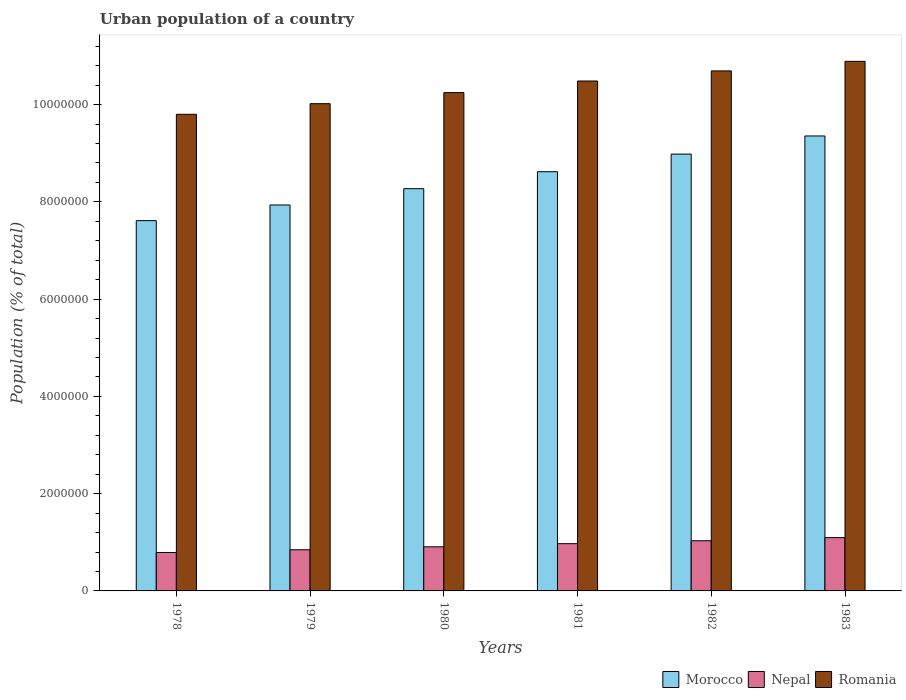How many different coloured bars are there?
Your answer should be compact. 3. Are the number of bars on each tick of the X-axis equal?
Your answer should be very brief. Yes. How many bars are there on the 3rd tick from the left?
Offer a terse response. 3. What is the label of the 5th group of bars from the left?
Keep it short and to the point. 1982. In how many cases, is the number of bars for a given year not equal to the number of legend labels?
Your answer should be very brief. 0. What is the urban population in Nepal in 1982?
Your answer should be compact. 1.03e+06. Across all years, what is the maximum urban population in Morocco?
Offer a very short reply. 9.36e+06. Across all years, what is the minimum urban population in Morocco?
Keep it short and to the point. 7.61e+06. In which year was the urban population in Nepal maximum?
Make the answer very short. 1983. In which year was the urban population in Nepal minimum?
Ensure brevity in your answer.  1978. What is the total urban population in Morocco in the graph?
Ensure brevity in your answer.  5.08e+07. What is the difference between the urban population in Nepal in 1978 and that in 1981?
Your answer should be compact. -1.81e+05. What is the difference between the urban population in Morocco in 1981 and the urban population in Nepal in 1980?
Keep it short and to the point. 7.71e+06. What is the average urban population in Nepal per year?
Your answer should be compact. 9.40e+05. In the year 1979, what is the difference between the urban population in Romania and urban population in Nepal?
Keep it short and to the point. 9.17e+06. What is the ratio of the urban population in Nepal in 1979 to that in 1981?
Provide a short and direct response. 0.87. Is the difference between the urban population in Romania in 1978 and 1982 greater than the difference between the urban population in Nepal in 1978 and 1982?
Provide a short and direct response. No. What is the difference between the highest and the second highest urban population in Morocco?
Your response must be concise. 3.73e+05. What is the difference between the highest and the lowest urban population in Nepal?
Your answer should be compact. 3.06e+05. In how many years, is the urban population in Nepal greater than the average urban population in Nepal taken over all years?
Give a very brief answer. 3. What does the 3rd bar from the left in 1983 represents?
Ensure brevity in your answer.  Romania. What does the 3rd bar from the right in 1980 represents?
Make the answer very short. Morocco. Is it the case that in every year, the sum of the urban population in Nepal and urban population in Romania is greater than the urban population in Morocco?
Give a very brief answer. Yes. Are all the bars in the graph horizontal?
Keep it short and to the point. No. Are the values on the major ticks of Y-axis written in scientific E-notation?
Offer a terse response. No. Does the graph contain any zero values?
Give a very brief answer. No. Does the graph contain grids?
Ensure brevity in your answer.  No. How many legend labels are there?
Offer a terse response. 3. What is the title of the graph?
Offer a very short reply. Urban population of a country. Does "Tanzania" appear as one of the legend labels in the graph?
Provide a succinct answer. No. What is the label or title of the X-axis?
Provide a succinct answer. Years. What is the label or title of the Y-axis?
Make the answer very short. Population (% of total). What is the Population (% of total) of Morocco in 1978?
Provide a succinct answer. 7.61e+06. What is the Population (% of total) of Nepal in 1978?
Your answer should be compact. 7.90e+05. What is the Population (% of total) in Romania in 1978?
Your answer should be compact. 9.80e+06. What is the Population (% of total) of Morocco in 1979?
Ensure brevity in your answer.  7.94e+06. What is the Population (% of total) in Nepal in 1979?
Give a very brief answer. 8.46e+05. What is the Population (% of total) of Romania in 1979?
Your answer should be very brief. 1.00e+07. What is the Population (% of total) of Morocco in 1980?
Offer a terse response. 8.27e+06. What is the Population (% of total) in Nepal in 1980?
Offer a very short reply. 9.07e+05. What is the Population (% of total) in Romania in 1980?
Make the answer very short. 1.02e+07. What is the Population (% of total) of Morocco in 1981?
Ensure brevity in your answer.  8.62e+06. What is the Population (% of total) in Nepal in 1981?
Keep it short and to the point. 9.72e+05. What is the Population (% of total) in Romania in 1981?
Keep it short and to the point. 1.05e+07. What is the Population (% of total) of Morocco in 1982?
Your response must be concise. 8.98e+06. What is the Population (% of total) in Nepal in 1982?
Offer a very short reply. 1.03e+06. What is the Population (% of total) of Romania in 1982?
Keep it short and to the point. 1.07e+07. What is the Population (% of total) of Morocco in 1983?
Offer a very short reply. 9.36e+06. What is the Population (% of total) in Nepal in 1983?
Ensure brevity in your answer.  1.10e+06. What is the Population (% of total) of Romania in 1983?
Ensure brevity in your answer.  1.09e+07. Across all years, what is the maximum Population (% of total) of Morocco?
Your answer should be very brief. 9.36e+06. Across all years, what is the maximum Population (% of total) of Nepal?
Your response must be concise. 1.10e+06. Across all years, what is the maximum Population (% of total) in Romania?
Provide a short and direct response. 1.09e+07. Across all years, what is the minimum Population (% of total) of Morocco?
Your answer should be compact. 7.61e+06. Across all years, what is the minimum Population (% of total) in Nepal?
Your answer should be very brief. 7.90e+05. Across all years, what is the minimum Population (% of total) of Romania?
Make the answer very short. 9.80e+06. What is the total Population (% of total) in Morocco in the graph?
Make the answer very short. 5.08e+07. What is the total Population (% of total) of Nepal in the graph?
Provide a short and direct response. 5.64e+06. What is the total Population (% of total) in Romania in the graph?
Provide a succinct answer. 6.21e+07. What is the difference between the Population (% of total) in Morocco in 1978 and that in 1979?
Give a very brief answer. -3.22e+05. What is the difference between the Population (% of total) in Nepal in 1978 and that in 1979?
Your answer should be very brief. -5.63e+04. What is the difference between the Population (% of total) of Romania in 1978 and that in 1979?
Provide a short and direct response. -2.19e+05. What is the difference between the Population (% of total) of Morocco in 1978 and that in 1980?
Ensure brevity in your answer.  -6.57e+05. What is the difference between the Population (% of total) in Nepal in 1978 and that in 1980?
Give a very brief answer. -1.17e+05. What is the difference between the Population (% of total) of Romania in 1978 and that in 1980?
Offer a very short reply. -4.46e+05. What is the difference between the Population (% of total) of Morocco in 1978 and that in 1981?
Provide a succinct answer. -1.01e+06. What is the difference between the Population (% of total) of Nepal in 1978 and that in 1981?
Offer a very short reply. -1.81e+05. What is the difference between the Population (% of total) in Romania in 1978 and that in 1981?
Make the answer very short. -6.85e+05. What is the difference between the Population (% of total) of Morocco in 1978 and that in 1982?
Provide a short and direct response. -1.37e+06. What is the difference between the Population (% of total) of Nepal in 1978 and that in 1982?
Ensure brevity in your answer.  -2.42e+05. What is the difference between the Population (% of total) in Romania in 1978 and that in 1982?
Give a very brief answer. -8.93e+05. What is the difference between the Population (% of total) in Morocco in 1978 and that in 1983?
Ensure brevity in your answer.  -1.74e+06. What is the difference between the Population (% of total) of Nepal in 1978 and that in 1983?
Provide a succinct answer. -3.06e+05. What is the difference between the Population (% of total) of Romania in 1978 and that in 1983?
Give a very brief answer. -1.09e+06. What is the difference between the Population (% of total) of Morocco in 1979 and that in 1980?
Your answer should be very brief. -3.35e+05. What is the difference between the Population (% of total) in Nepal in 1979 and that in 1980?
Offer a terse response. -6.05e+04. What is the difference between the Population (% of total) of Romania in 1979 and that in 1980?
Your answer should be very brief. -2.27e+05. What is the difference between the Population (% of total) of Morocco in 1979 and that in 1981?
Give a very brief answer. -6.84e+05. What is the difference between the Population (% of total) of Nepal in 1979 and that in 1981?
Provide a short and direct response. -1.25e+05. What is the difference between the Population (% of total) of Romania in 1979 and that in 1981?
Offer a terse response. -4.66e+05. What is the difference between the Population (% of total) in Morocco in 1979 and that in 1982?
Provide a short and direct response. -1.05e+06. What is the difference between the Population (% of total) of Nepal in 1979 and that in 1982?
Ensure brevity in your answer.  -1.85e+05. What is the difference between the Population (% of total) in Romania in 1979 and that in 1982?
Make the answer very short. -6.74e+05. What is the difference between the Population (% of total) in Morocco in 1979 and that in 1983?
Offer a very short reply. -1.42e+06. What is the difference between the Population (% of total) in Nepal in 1979 and that in 1983?
Provide a succinct answer. -2.49e+05. What is the difference between the Population (% of total) in Romania in 1979 and that in 1983?
Provide a short and direct response. -8.70e+05. What is the difference between the Population (% of total) of Morocco in 1980 and that in 1981?
Your answer should be compact. -3.49e+05. What is the difference between the Population (% of total) of Nepal in 1980 and that in 1981?
Ensure brevity in your answer.  -6.46e+04. What is the difference between the Population (% of total) in Romania in 1980 and that in 1981?
Your answer should be very brief. -2.39e+05. What is the difference between the Population (% of total) of Morocco in 1980 and that in 1982?
Your answer should be compact. -7.12e+05. What is the difference between the Population (% of total) in Nepal in 1980 and that in 1982?
Make the answer very short. -1.25e+05. What is the difference between the Population (% of total) in Romania in 1980 and that in 1982?
Provide a short and direct response. -4.46e+05. What is the difference between the Population (% of total) of Morocco in 1980 and that in 1983?
Keep it short and to the point. -1.08e+06. What is the difference between the Population (% of total) of Nepal in 1980 and that in 1983?
Make the answer very short. -1.89e+05. What is the difference between the Population (% of total) in Romania in 1980 and that in 1983?
Give a very brief answer. -6.43e+05. What is the difference between the Population (% of total) in Morocco in 1981 and that in 1982?
Make the answer very short. -3.63e+05. What is the difference between the Population (% of total) in Nepal in 1981 and that in 1982?
Provide a short and direct response. -6.03e+04. What is the difference between the Population (% of total) of Romania in 1981 and that in 1982?
Provide a succinct answer. -2.08e+05. What is the difference between the Population (% of total) in Morocco in 1981 and that in 1983?
Offer a very short reply. -7.35e+05. What is the difference between the Population (% of total) in Nepal in 1981 and that in 1983?
Ensure brevity in your answer.  -1.24e+05. What is the difference between the Population (% of total) in Romania in 1981 and that in 1983?
Make the answer very short. -4.04e+05. What is the difference between the Population (% of total) of Morocco in 1982 and that in 1983?
Your response must be concise. -3.73e+05. What is the difference between the Population (% of total) of Nepal in 1982 and that in 1983?
Provide a succinct answer. -6.39e+04. What is the difference between the Population (% of total) in Romania in 1982 and that in 1983?
Offer a very short reply. -1.96e+05. What is the difference between the Population (% of total) in Morocco in 1978 and the Population (% of total) in Nepal in 1979?
Your response must be concise. 6.77e+06. What is the difference between the Population (% of total) of Morocco in 1978 and the Population (% of total) of Romania in 1979?
Provide a short and direct response. -2.41e+06. What is the difference between the Population (% of total) in Nepal in 1978 and the Population (% of total) in Romania in 1979?
Ensure brevity in your answer.  -9.23e+06. What is the difference between the Population (% of total) of Morocco in 1978 and the Population (% of total) of Nepal in 1980?
Keep it short and to the point. 6.71e+06. What is the difference between the Population (% of total) in Morocco in 1978 and the Population (% of total) in Romania in 1980?
Your response must be concise. -2.63e+06. What is the difference between the Population (% of total) of Nepal in 1978 and the Population (% of total) of Romania in 1980?
Offer a very short reply. -9.46e+06. What is the difference between the Population (% of total) of Morocco in 1978 and the Population (% of total) of Nepal in 1981?
Your answer should be very brief. 6.64e+06. What is the difference between the Population (% of total) of Morocco in 1978 and the Population (% of total) of Romania in 1981?
Your answer should be compact. -2.87e+06. What is the difference between the Population (% of total) in Nepal in 1978 and the Population (% of total) in Romania in 1981?
Offer a terse response. -9.70e+06. What is the difference between the Population (% of total) of Morocco in 1978 and the Population (% of total) of Nepal in 1982?
Offer a very short reply. 6.58e+06. What is the difference between the Population (% of total) in Morocco in 1978 and the Population (% of total) in Romania in 1982?
Offer a terse response. -3.08e+06. What is the difference between the Population (% of total) of Nepal in 1978 and the Population (% of total) of Romania in 1982?
Provide a short and direct response. -9.90e+06. What is the difference between the Population (% of total) in Morocco in 1978 and the Population (% of total) in Nepal in 1983?
Your response must be concise. 6.52e+06. What is the difference between the Population (% of total) in Morocco in 1978 and the Population (% of total) in Romania in 1983?
Your response must be concise. -3.28e+06. What is the difference between the Population (% of total) in Nepal in 1978 and the Population (% of total) in Romania in 1983?
Ensure brevity in your answer.  -1.01e+07. What is the difference between the Population (% of total) in Morocco in 1979 and the Population (% of total) in Nepal in 1980?
Your answer should be very brief. 7.03e+06. What is the difference between the Population (% of total) of Morocco in 1979 and the Population (% of total) of Romania in 1980?
Make the answer very short. -2.31e+06. What is the difference between the Population (% of total) of Nepal in 1979 and the Population (% of total) of Romania in 1980?
Keep it short and to the point. -9.40e+06. What is the difference between the Population (% of total) in Morocco in 1979 and the Population (% of total) in Nepal in 1981?
Ensure brevity in your answer.  6.96e+06. What is the difference between the Population (% of total) in Morocco in 1979 and the Population (% of total) in Romania in 1981?
Provide a succinct answer. -2.55e+06. What is the difference between the Population (% of total) in Nepal in 1979 and the Population (% of total) in Romania in 1981?
Provide a short and direct response. -9.64e+06. What is the difference between the Population (% of total) of Morocco in 1979 and the Population (% of total) of Nepal in 1982?
Offer a terse response. 6.90e+06. What is the difference between the Population (% of total) of Morocco in 1979 and the Population (% of total) of Romania in 1982?
Your answer should be compact. -2.76e+06. What is the difference between the Population (% of total) in Nepal in 1979 and the Population (% of total) in Romania in 1982?
Your answer should be very brief. -9.85e+06. What is the difference between the Population (% of total) in Morocco in 1979 and the Population (% of total) in Nepal in 1983?
Your answer should be compact. 6.84e+06. What is the difference between the Population (% of total) in Morocco in 1979 and the Population (% of total) in Romania in 1983?
Keep it short and to the point. -2.95e+06. What is the difference between the Population (% of total) of Nepal in 1979 and the Population (% of total) of Romania in 1983?
Your response must be concise. -1.00e+07. What is the difference between the Population (% of total) in Morocco in 1980 and the Population (% of total) in Nepal in 1981?
Provide a succinct answer. 7.30e+06. What is the difference between the Population (% of total) in Morocco in 1980 and the Population (% of total) in Romania in 1981?
Keep it short and to the point. -2.21e+06. What is the difference between the Population (% of total) in Nepal in 1980 and the Population (% of total) in Romania in 1981?
Your answer should be compact. -9.58e+06. What is the difference between the Population (% of total) of Morocco in 1980 and the Population (% of total) of Nepal in 1982?
Provide a short and direct response. 7.24e+06. What is the difference between the Population (% of total) in Morocco in 1980 and the Population (% of total) in Romania in 1982?
Offer a very short reply. -2.42e+06. What is the difference between the Population (% of total) of Nepal in 1980 and the Population (% of total) of Romania in 1982?
Ensure brevity in your answer.  -9.79e+06. What is the difference between the Population (% of total) of Morocco in 1980 and the Population (% of total) of Nepal in 1983?
Ensure brevity in your answer.  7.18e+06. What is the difference between the Population (% of total) in Morocco in 1980 and the Population (% of total) in Romania in 1983?
Your answer should be very brief. -2.62e+06. What is the difference between the Population (% of total) in Nepal in 1980 and the Population (% of total) in Romania in 1983?
Your answer should be very brief. -9.98e+06. What is the difference between the Population (% of total) in Morocco in 1981 and the Population (% of total) in Nepal in 1982?
Ensure brevity in your answer.  7.59e+06. What is the difference between the Population (% of total) of Morocco in 1981 and the Population (% of total) of Romania in 1982?
Your answer should be very brief. -2.07e+06. What is the difference between the Population (% of total) in Nepal in 1981 and the Population (% of total) in Romania in 1982?
Your answer should be compact. -9.72e+06. What is the difference between the Population (% of total) in Morocco in 1981 and the Population (% of total) in Nepal in 1983?
Your answer should be very brief. 7.52e+06. What is the difference between the Population (% of total) of Morocco in 1981 and the Population (% of total) of Romania in 1983?
Your response must be concise. -2.27e+06. What is the difference between the Population (% of total) of Nepal in 1981 and the Population (% of total) of Romania in 1983?
Your answer should be compact. -9.92e+06. What is the difference between the Population (% of total) in Morocco in 1982 and the Population (% of total) in Nepal in 1983?
Provide a short and direct response. 7.89e+06. What is the difference between the Population (% of total) of Morocco in 1982 and the Population (% of total) of Romania in 1983?
Offer a terse response. -1.91e+06. What is the difference between the Population (% of total) of Nepal in 1982 and the Population (% of total) of Romania in 1983?
Keep it short and to the point. -9.86e+06. What is the average Population (% of total) in Morocco per year?
Give a very brief answer. 8.46e+06. What is the average Population (% of total) of Nepal per year?
Your answer should be very brief. 9.40e+05. What is the average Population (% of total) in Romania per year?
Provide a short and direct response. 1.04e+07. In the year 1978, what is the difference between the Population (% of total) in Morocco and Population (% of total) in Nepal?
Your answer should be very brief. 6.82e+06. In the year 1978, what is the difference between the Population (% of total) of Morocco and Population (% of total) of Romania?
Ensure brevity in your answer.  -2.19e+06. In the year 1978, what is the difference between the Population (% of total) of Nepal and Population (% of total) of Romania?
Offer a very short reply. -9.01e+06. In the year 1979, what is the difference between the Population (% of total) in Morocco and Population (% of total) in Nepal?
Ensure brevity in your answer.  7.09e+06. In the year 1979, what is the difference between the Population (% of total) in Morocco and Population (% of total) in Romania?
Offer a terse response. -2.08e+06. In the year 1979, what is the difference between the Population (% of total) in Nepal and Population (% of total) in Romania?
Your answer should be compact. -9.17e+06. In the year 1980, what is the difference between the Population (% of total) of Morocco and Population (% of total) of Nepal?
Make the answer very short. 7.36e+06. In the year 1980, what is the difference between the Population (% of total) of Morocco and Population (% of total) of Romania?
Keep it short and to the point. -1.98e+06. In the year 1980, what is the difference between the Population (% of total) in Nepal and Population (% of total) in Romania?
Your response must be concise. -9.34e+06. In the year 1981, what is the difference between the Population (% of total) in Morocco and Population (% of total) in Nepal?
Ensure brevity in your answer.  7.65e+06. In the year 1981, what is the difference between the Population (% of total) of Morocco and Population (% of total) of Romania?
Offer a terse response. -1.87e+06. In the year 1981, what is the difference between the Population (% of total) in Nepal and Population (% of total) in Romania?
Keep it short and to the point. -9.51e+06. In the year 1982, what is the difference between the Population (% of total) of Morocco and Population (% of total) of Nepal?
Offer a very short reply. 7.95e+06. In the year 1982, what is the difference between the Population (% of total) in Morocco and Population (% of total) in Romania?
Ensure brevity in your answer.  -1.71e+06. In the year 1982, what is the difference between the Population (% of total) of Nepal and Population (% of total) of Romania?
Your response must be concise. -9.66e+06. In the year 1983, what is the difference between the Population (% of total) of Morocco and Population (% of total) of Nepal?
Give a very brief answer. 8.26e+06. In the year 1983, what is the difference between the Population (% of total) in Morocco and Population (% of total) in Romania?
Your answer should be compact. -1.53e+06. In the year 1983, what is the difference between the Population (% of total) in Nepal and Population (% of total) in Romania?
Your answer should be very brief. -9.79e+06. What is the ratio of the Population (% of total) of Morocco in 1978 to that in 1979?
Give a very brief answer. 0.96. What is the ratio of the Population (% of total) of Nepal in 1978 to that in 1979?
Your answer should be compact. 0.93. What is the ratio of the Population (% of total) in Romania in 1978 to that in 1979?
Your answer should be compact. 0.98. What is the ratio of the Population (% of total) in Morocco in 1978 to that in 1980?
Offer a very short reply. 0.92. What is the ratio of the Population (% of total) of Nepal in 1978 to that in 1980?
Provide a succinct answer. 0.87. What is the ratio of the Population (% of total) in Romania in 1978 to that in 1980?
Make the answer very short. 0.96. What is the ratio of the Population (% of total) in Morocco in 1978 to that in 1981?
Keep it short and to the point. 0.88. What is the ratio of the Population (% of total) of Nepal in 1978 to that in 1981?
Offer a terse response. 0.81. What is the ratio of the Population (% of total) of Romania in 1978 to that in 1981?
Your answer should be very brief. 0.93. What is the ratio of the Population (% of total) of Morocco in 1978 to that in 1982?
Your response must be concise. 0.85. What is the ratio of the Population (% of total) in Nepal in 1978 to that in 1982?
Provide a short and direct response. 0.77. What is the ratio of the Population (% of total) in Romania in 1978 to that in 1982?
Your answer should be very brief. 0.92. What is the ratio of the Population (% of total) of Morocco in 1978 to that in 1983?
Provide a short and direct response. 0.81. What is the ratio of the Population (% of total) of Nepal in 1978 to that in 1983?
Ensure brevity in your answer.  0.72. What is the ratio of the Population (% of total) of Morocco in 1979 to that in 1980?
Offer a very short reply. 0.96. What is the ratio of the Population (% of total) of Nepal in 1979 to that in 1980?
Keep it short and to the point. 0.93. What is the ratio of the Population (% of total) in Romania in 1979 to that in 1980?
Your answer should be very brief. 0.98. What is the ratio of the Population (% of total) of Morocco in 1979 to that in 1981?
Your answer should be very brief. 0.92. What is the ratio of the Population (% of total) in Nepal in 1979 to that in 1981?
Your answer should be very brief. 0.87. What is the ratio of the Population (% of total) in Romania in 1979 to that in 1981?
Offer a very short reply. 0.96. What is the ratio of the Population (% of total) in Morocco in 1979 to that in 1982?
Provide a short and direct response. 0.88. What is the ratio of the Population (% of total) in Nepal in 1979 to that in 1982?
Your answer should be very brief. 0.82. What is the ratio of the Population (% of total) in Romania in 1979 to that in 1982?
Your response must be concise. 0.94. What is the ratio of the Population (% of total) of Morocco in 1979 to that in 1983?
Your answer should be compact. 0.85. What is the ratio of the Population (% of total) in Nepal in 1979 to that in 1983?
Make the answer very short. 0.77. What is the ratio of the Population (% of total) of Romania in 1979 to that in 1983?
Your answer should be compact. 0.92. What is the ratio of the Population (% of total) of Morocco in 1980 to that in 1981?
Ensure brevity in your answer.  0.96. What is the ratio of the Population (% of total) of Nepal in 1980 to that in 1981?
Give a very brief answer. 0.93. What is the ratio of the Population (% of total) of Romania in 1980 to that in 1981?
Make the answer very short. 0.98. What is the ratio of the Population (% of total) of Morocco in 1980 to that in 1982?
Keep it short and to the point. 0.92. What is the ratio of the Population (% of total) in Nepal in 1980 to that in 1982?
Give a very brief answer. 0.88. What is the ratio of the Population (% of total) of Romania in 1980 to that in 1982?
Your answer should be compact. 0.96. What is the ratio of the Population (% of total) in Morocco in 1980 to that in 1983?
Your answer should be very brief. 0.88. What is the ratio of the Population (% of total) in Nepal in 1980 to that in 1983?
Ensure brevity in your answer.  0.83. What is the ratio of the Population (% of total) of Romania in 1980 to that in 1983?
Offer a very short reply. 0.94. What is the ratio of the Population (% of total) in Morocco in 1981 to that in 1982?
Your answer should be very brief. 0.96. What is the ratio of the Population (% of total) of Nepal in 1981 to that in 1982?
Provide a succinct answer. 0.94. What is the ratio of the Population (% of total) of Romania in 1981 to that in 1982?
Make the answer very short. 0.98. What is the ratio of the Population (% of total) in Morocco in 1981 to that in 1983?
Your response must be concise. 0.92. What is the ratio of the Population (% of total) of Nepal in 1981 to that in 1983?
Keep it short and to the point. 0.89. What is the ratio of the Population (% of total) in Romania in 1981 to that in 1983?
Provide a succinct answer. 0.96. What is the ratio of the Population (% of total) of Morocco in 1982 to that in 1983?
Offer a terse response. 0.96. What is the ratio of the Population (% of total) in Nepal in 1982 to that in 1983?
Make the answer very short. 0.94. What is the difference between the highest and the second highest Population (% of total) in Morocco?
Offer a very short reply. 3.73e+05. What is the difference between the highest and the second highest Population (% of total) of Nepal?
Offer a terse response. 6.39e+04. What is the difference between the highest and the second highest Population (% of total) in Romania?
Give a very brief answer. 1.96e+05. What is the difference between the highest and the lowest Population (% of total) of Morocco?
Offer a terse response. 1.74e+06. What is the difference between the highest and the lowest Population (% of total) in Nepal?
Provide a short and direct response. 3.06e+05. What is the difference between the highest and the lowest Population (% of total) in Romania?
Ensure brevity in your answer.  1.09e+06. 